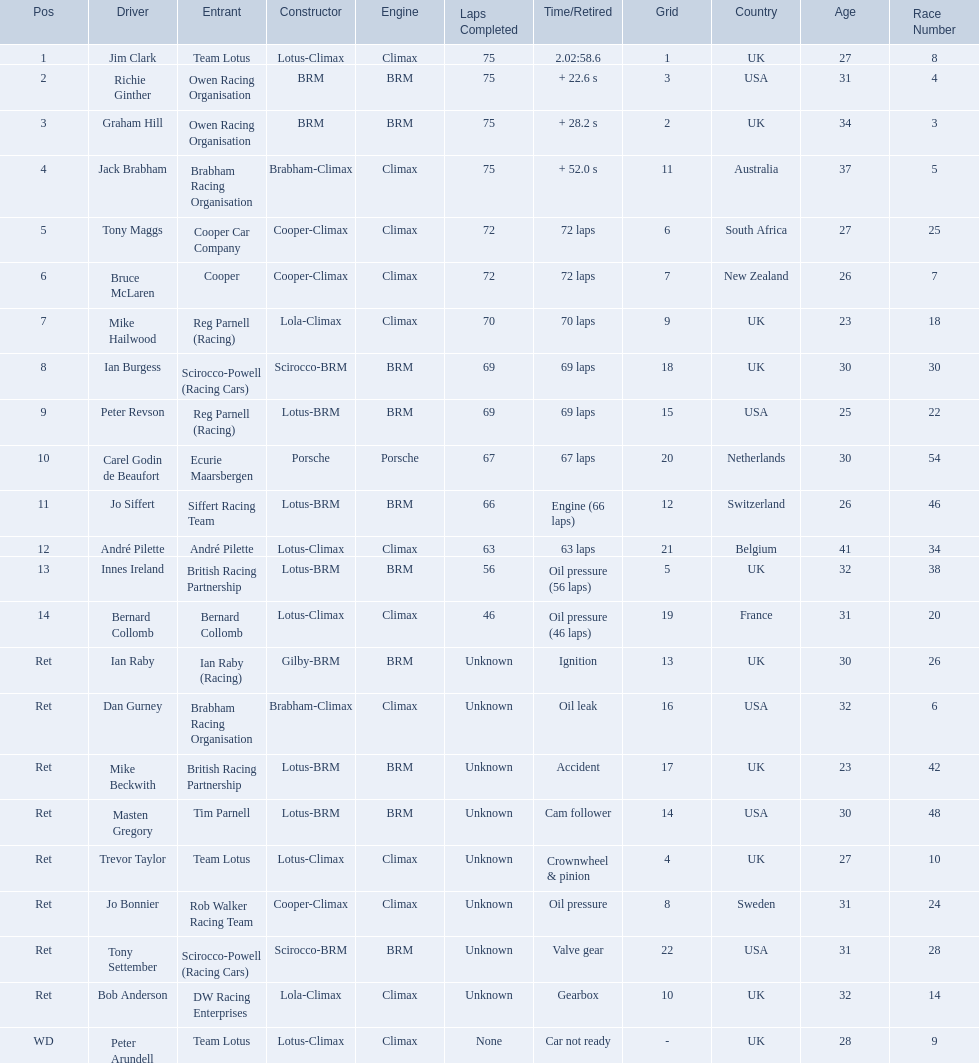Can you give me this table as a dict? {'header': ['Pos', 'Driver', 'Entrant', 'Constructor', 'Engine', 'Laps Completed', 'Time/Retired', 'Grid', 'Country', 'Age', 'Race Number'], 'rows': [['1', 'Jim Clark', 'Team Lotus', 'Lotus-Climax', 'Climax', '75', '2.02:58.6', '1', 'UK', '27', '8'], ['2', 'Richie Ginther', 'Owen Racing Organisation', 'BRM', 'BRM', '75', '+ 22.6 s', '3', 'USA', '31', '4'], ['3', 'Graham Hill', 'Owen Racing Organisation', 'BRM', 'BRM', '75', '+ 28.2 s', '2', 'UK', '34', '3'], ['4', 'Jack Brabham', 'Brabham Racing Organisation', 'Brabham-Climax', 'Climax', '75', '+ 52.0 s', '11', 'Australia', '37', '5'], ['5', 'Tony Maggs', 'Cooper Car Company', 'Cooper-Climax', 'Climax', '72', '72 laps', '6', 'South Africa', '27', '25'], ['6', 'Bruce McLaren', 'Cooper', 'Cooper-Climax', 'Climax', '72', '72 laps', '7', 'New Zealand', '26', '7'], ['7', 'Mike Hailwood', 'Reg Parnell (Racing)', 'Lola-Climax', 'Climax', '70', '70 laps', '9', 'UK', '23', '18'], ['8', 'Ian Burgess', 'Scirocco-Powell (Racing Cars)', 'Scirocco-BRM', 'BRM', '69', '69 laps', '18', 'UK', '30', '30'], ['9', 'Peter Revson', 'Reg Parnell (Racing)', 'Lotus-BRM', 'BRM', '69', '69 laps', '15', 'USA', '25', '22'], ['10', 'Carel Godin de Beaufort', 'Ecurie Maarsbergen', 'Porsche', 'Porsche', '67', '67 laps', '20', 'Netherlands', '30', '54'], ['11', 'Jo Siffert', 'Siffert Racing Team', 'Lotus-BRM', 'BRM', '66', 'Engine (66 laps)', '12', 'Switzerland', '26', '46'], ['12', 'André Pilette', 'André Pilette', 'Lotus-Climax', 'Climax', '63', '63 laps', '21', 'Belgium', '41', '34'], ['13', 'Innes Ireland', 'British Racing Partnership', 'Lotus-BRM', 'BRM', '56', 'Oil pressure (56 laps)', '5', 'UK', '32', '38'], ['14', 'Bernard Collomb', 'Bernard Collomb', 'Lotus-Climax', 'Climax', '46', 'Oil pressure (46 laps)', '19', 'France', '31', '20'], ['Ret', 'Ian Raby', 'Ian Raby (Racing)', 'Gilby-BRM', 'BRM', 'Unknown', 'Ignition', '13', 'UK', '30', '26'], ['Ret', 'Dan Gurney', 'Brabham Racing Organisation', 'Brabham-Climax', 'Climax', 'Unknown', 'Oil leak', '16', 'USA', '32', '6'], ['Ret', 'Mike Beckwith', 'British Racing Partnership', 'Lotus-BRM', 'BRM', 'Unknown', 'Accident', '17', 'UK', '23', '42'], ['Ret', 'Masten Gregory', 'Tim Parnell', 'Lotus-BRM', 'BRM', 'Unknown', 'Cam follower', '14', 'USA', '30', '48'], ['Ret', 'Trevor Taylor', 'Team Lotus', 'Lotus-Climax', 'Climax', 'Unknown', 'Crownwheel & pinion', '4', 'UK', '27', '10'], ['Ret', 'Jo Bonnier', 'Rob Walker Racing Team', 'Cooper-Climax', 'Climax', 'Unknown', 'Oil pressure', '8', 'Sweden', '31', '24'], ['Ret', 'Tony Settember', 'Scirocco-Powell (Racing Cars)', 'Scirocco-BRM', 'BRM', 'Unknown', 'Valve gear', '22', 'USA', '31', '28'], ['Ret', 'Bob Anderson', 'DW Racing Enterprises', 'Lola-Climax', 'Climax', 'Unknown', 'Gearbox', '10', 'UK', '32', '14'], ['WD', 'Peter Arundell', 'Team Lotus', 'Lotus-Climax', 'Climax', 'None', 'Car not ready', '-', 'UK', '28', '9']]} Who all drive cars that were constructed bur climax? Jim Clark, Jack Brabham, Tony Maggs, Bruce McLaren, Mike Hailwood, André Pilette, Bernard Collomb, Dan Gurney, Trevor Taylor, Jo Bonnier, Bob Anderson, Peter Arundell. Which driver's climax constructed cars started in the top 10 on the grid? Jim Clark, Tony Maggs, Bruce McLaren, Mike Hailwood, Jo Bonnier, Bob Anderson. Of the top 10 starting climax constructed drivers, which ones did not finish the race? Jo Bonnier, Bob Anderson. What was the failure that was engine related that took out the driver of the climax constructed car that did not finish even though it started in the top 10? Oil pressure. 